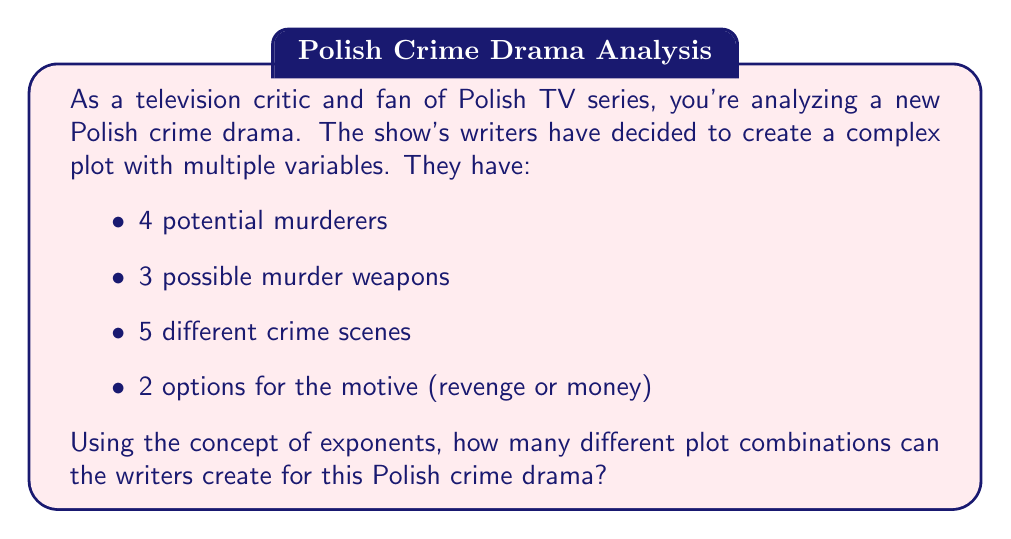Can you answer this question? To solve this problem, we need to use the multiplication principle of counting, which can be expressed using exponents. Here's how we can break it down:

1. For each element of the plot (murderer, weapon, scene, motive), we have a certain number of choices.

2. The total number of combinations is the product of the number of choices for each element.

3. We can express this using exponents as follows:

   $$ \text{Total combinations} = 4 \times 3 \times 5 \times 2 $$

4. This can be rewritten as:

   $$ \text{Total combinations} = 4^1 \times 3^1 \times 5^1 \times 2^1 $$

5. The exponent of 1 for each base represents that we are choosing one option from each category.

6. Calculating this:
   $$ 4 \times 3 \times 5 \times 2 = 120 $$

Therefore, the writers can create 120 different plot combinations for this Polish crime drama.
Answer: $$ 120 \text{ plot combinations} $$ 